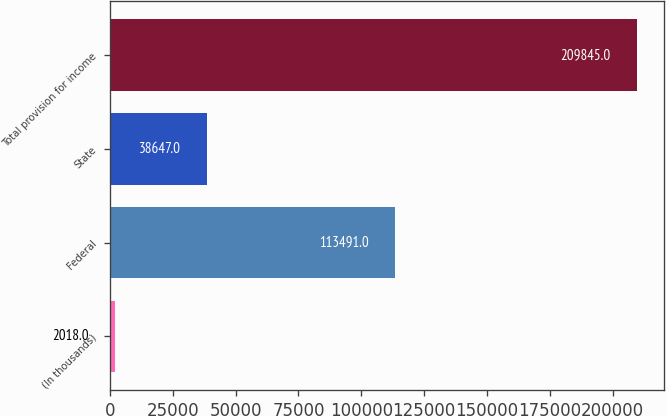<chart> <loc_0><loc_0><loc_500><loc_500><bar_chart><fcel>(In thousands)<fcel>Federal<fcel>State<fcel>Total provision for income<nl><fcel>2018<fcel>113491<fcel>38647<fcel>209845<nl></chart> 